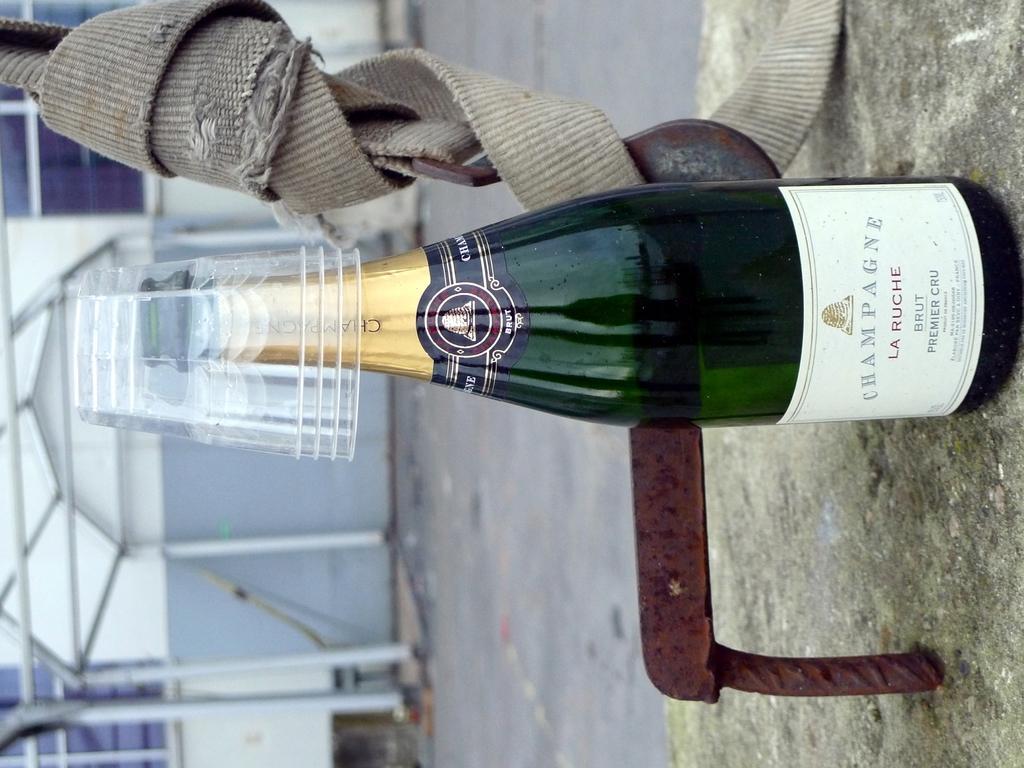Can you describe this image briefly? In the middle of the image there is a bottle on the bottle there are some glasses. Behind the bottle there is a building. 